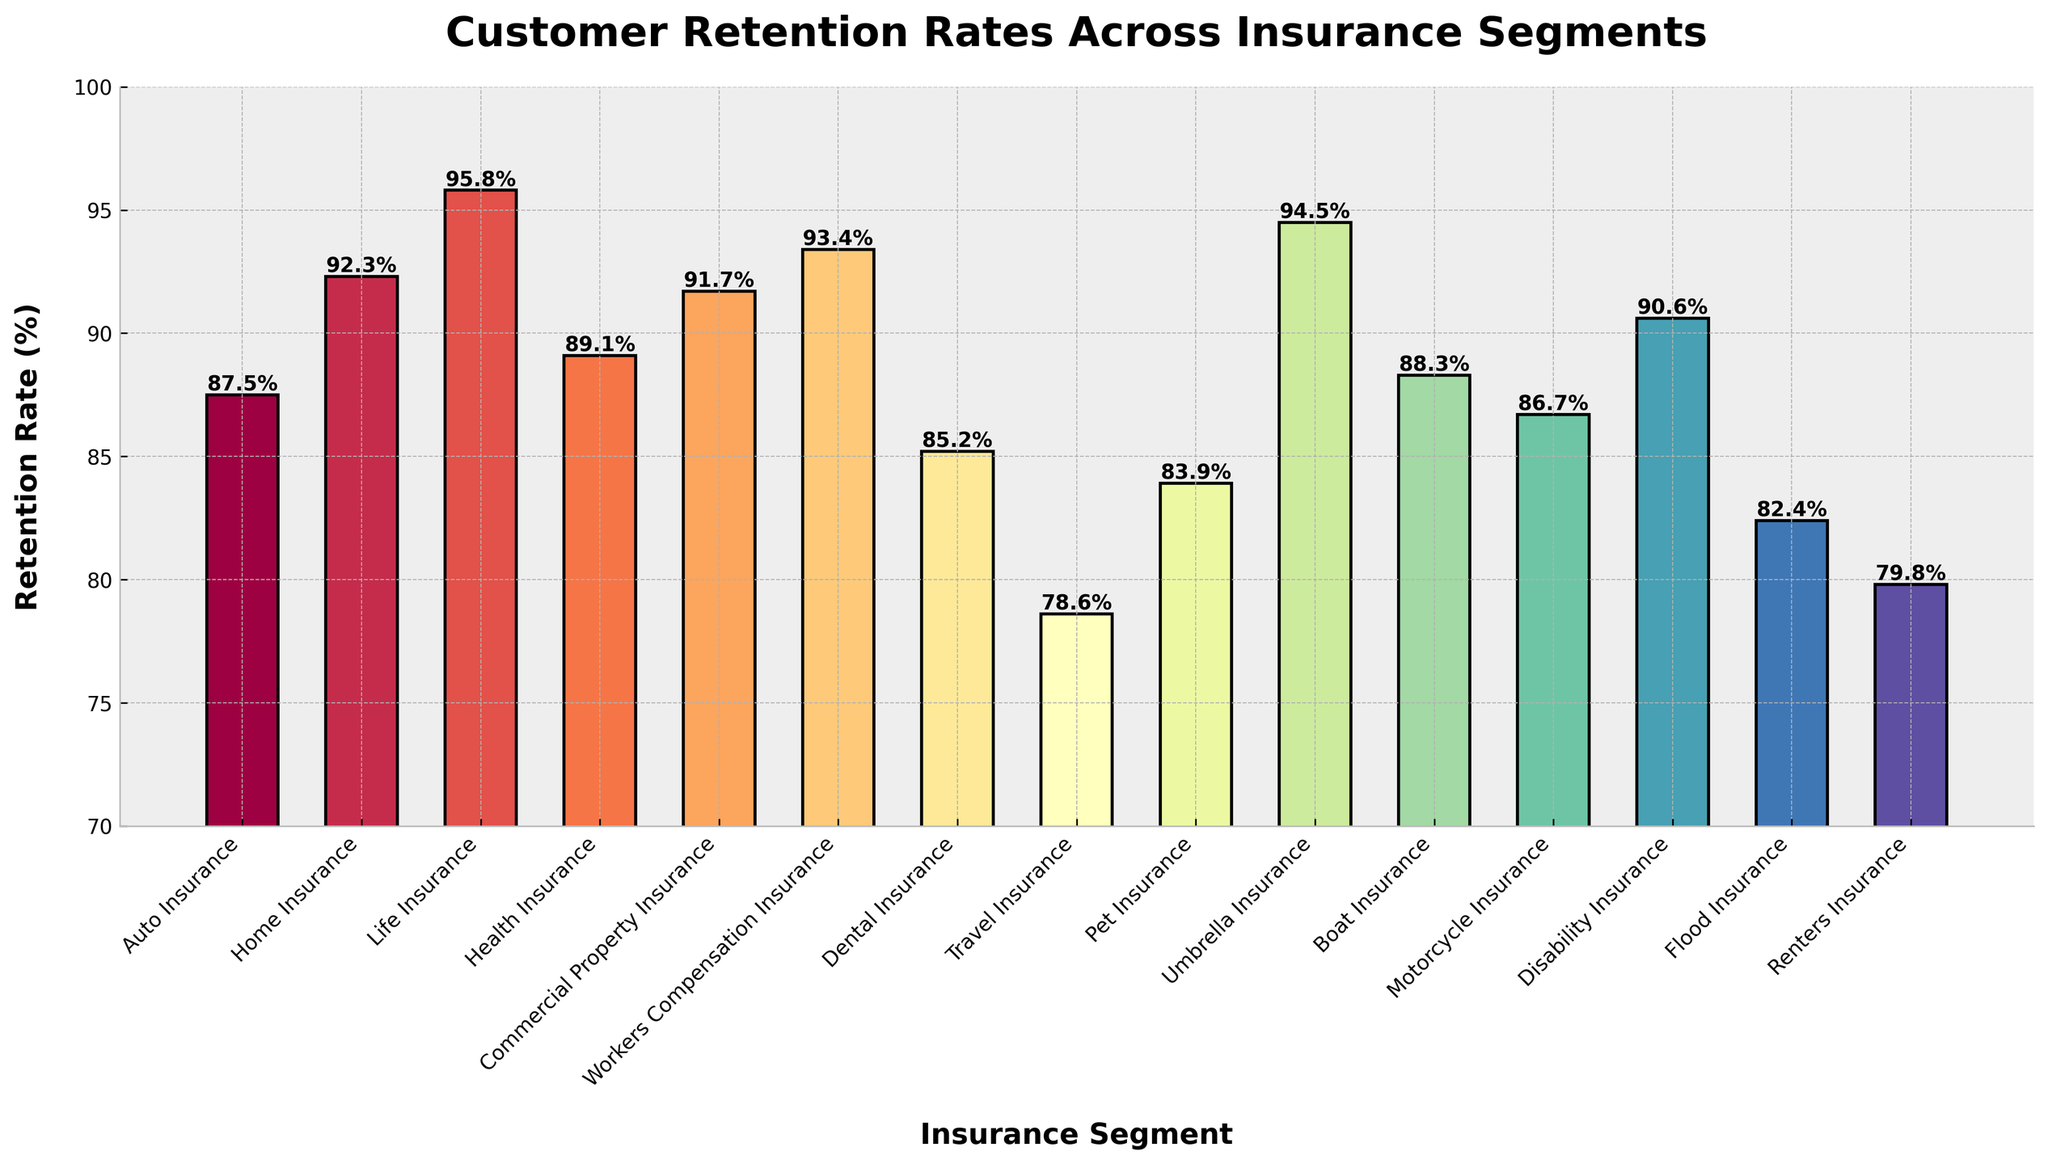What is the insurance segment with the highest retention rate? The highest bar on the chart represents the insurance segment with the highest retention rate. Here, it's Life Insurance with a retention rate of 95.8%.
Answer: Life Insurance What is the difference in retention rates between Auto Insurance and Travel Insurance? Compare the bar heights for Auto Insurance and Travel Insurance. Auto Insurance has a retention rate of 87.5%, and Travel Insurance has 78.6%. The difference is 87.5% - 78.6% = 8.9%.
Answer: 8.9% Which insurance segments have a retention rate above 90%? Look for bars that exceed the 90% mark on the y-axis. The segments are Home Insurance (92.3%), Life Insurance (95.8%), Commercial Property Insurance (91.7%), Workers Compensation Insurance (93.4%), Umbrella Insurance (94.5%), and Disability Insurance (90.6%).
Answer: Home Insurance, Life Insurance, Commercial Property Insurance, Workers Compensation Insurance, Umbrella Insurance, Disability Insurance What is the average retention rate of Home Insurance, Health Insurance, and Boat Insurance? Sum the retention rates of these three segments and divide by the number of segments. (92.3% + 89.1% + 88.3%) / 3 = 89.9%.
Answer: 89.9% How many insurance segments have a retention rate below 85%? Count the bars that fall below the 85% mark on the y-axis. These segments are Dental Insurance (85.2%), Travel Insurance (78.6%), Pet Insurance (83.9%), Flood Insurance (82.4%), and Renters Insurance (79.8%).
Answer: 5 